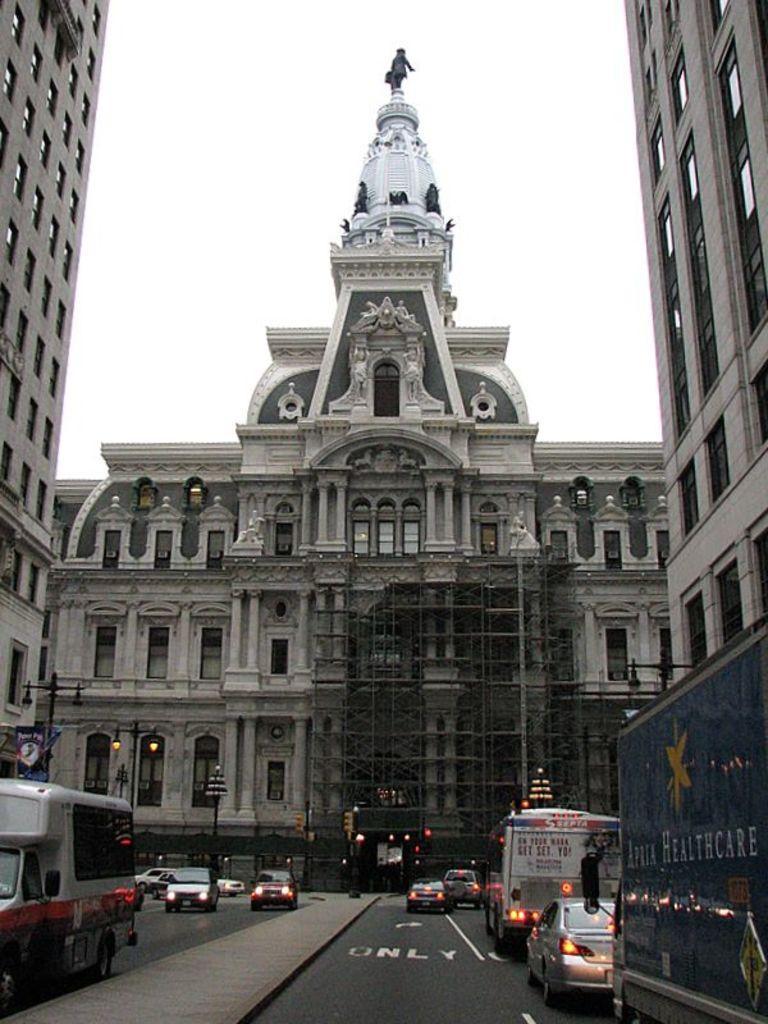In one or two sentences, can you explain what this image depicts? In this image there are buildings, light poles, vehicles, sky, statues, hoarding and objects. Vehicles are on the road. 